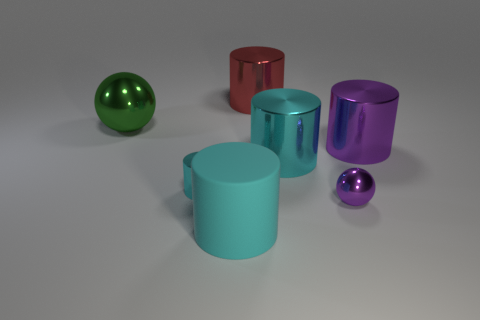Add 1 tiny gray metallic things. How many objects exist? 8 Subtract all large purple cylinders. How many cylinders are left? 4 Subtract all balls. How many objects are left? 5 Subtract 1 spheres. How many spheres are left? 1 Subtract all red cylinders. How many cylinders are left? 4 Add 2 cyan metal things. How many cyan metal things are left? 4 Add 4 tiny spheres. How many tiny spheres exist? 5 Subtract 0 green cylinders. How many objects are left? 7 Subtract all green cylinders. Subtract all brown blocks. How many cylinders are left? 5 Subtract all yellow balls. How many blue cylinders are left? 0 